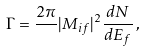<formula> <loc_0><loc_0><loc_500><loc_500>\Gamma = \frac { 2 \pi } { } | M _ { i f } | ^ { 2 } \frac { d N } { d E _ { f } } \, ,</formula> 